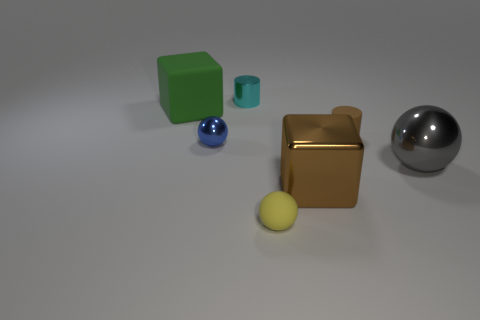Subtract all big spheres. How many spheres are left? 2 Add 2 metal objects. How many objects exist? 9 Subtract all cubes. How many objects are left? 5 Subtract 1 spheres. How many spheres are left? 2 Subtract all yellow balls. How many balls are left? 2 Add 1 large blue matte cylinders. How many large blue matte cylinders exist? 1 Subtract 1 cyan cylinders. How many objects are left? 6 Subtract all brown cylinders. Subtract all gray balls. How many cylinders are left? 1 Subtract all green rubber blocks. Subtract all big brown metal objects. How many objects are left? 5 Add 1 cyan cylinders. How many cyan cylinders are left? 2 